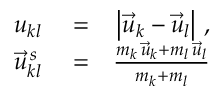Convert formula to latex. <formula><loc_0><loc_0><loc_500><loc_500>\begin{array} { r l r } { u _ { k l } } & = } & { \left | \vec { u } _ { k } - \vec { u } _ { l } \right | \, , } \\ { \vec { u } _ { k l } ^ { \, s } } & = } & { \frac { m _ { k } \, \vec { u } _ { k } + m _ { l } \, \vec { u } _ { l } } { m _ { k } + m _ { l } } } \end{array}</formula> 